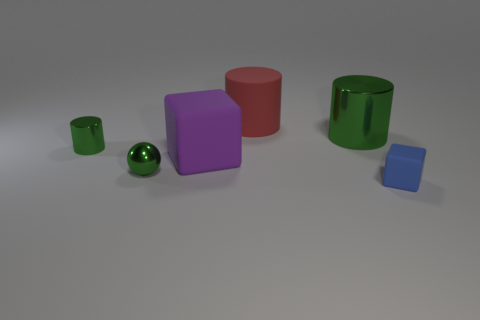There is a big object that is behind the green shiny cylinder to the right of the large purple cube; what shape is it?
Provide a short and direct response. Cylinder. Is there anything else of the same color as the tiny shiny ball?
Your answer should be very brief. Yes. Are there any shiny objects that are to the left of the green object in front of the green thing left of the sphere?
Offer a terse response. Yes. There is a cylinder behind the big metallic cylinder; does it have the same color as the matte cube to the right of the red matte cylinder?
Provide a short and direct response. No. There is a green cylinder that is the same size as the blue object; what is its material?
Provide a short and direct response. Metal. There is a green object that is to the left of the small green shiny object to the right of the shiny cylinder left of the green ball; what is its size?
Offer a very short reply. Small. How many other objects are there of the same material as the blue object?
Ensure brevity in your answer.  2. What size is the rubber thing that is to the right of the matte cylinder?
Keep it short and to the point. Small. What number of matte things are both in front of the small green cylinder and behind the small matte object?
Make the answer very short. 1. What material is the cylinder to the left of the rubber cube left of the tiny blue rubber thing?
Provide a short and direct response. Metal. 